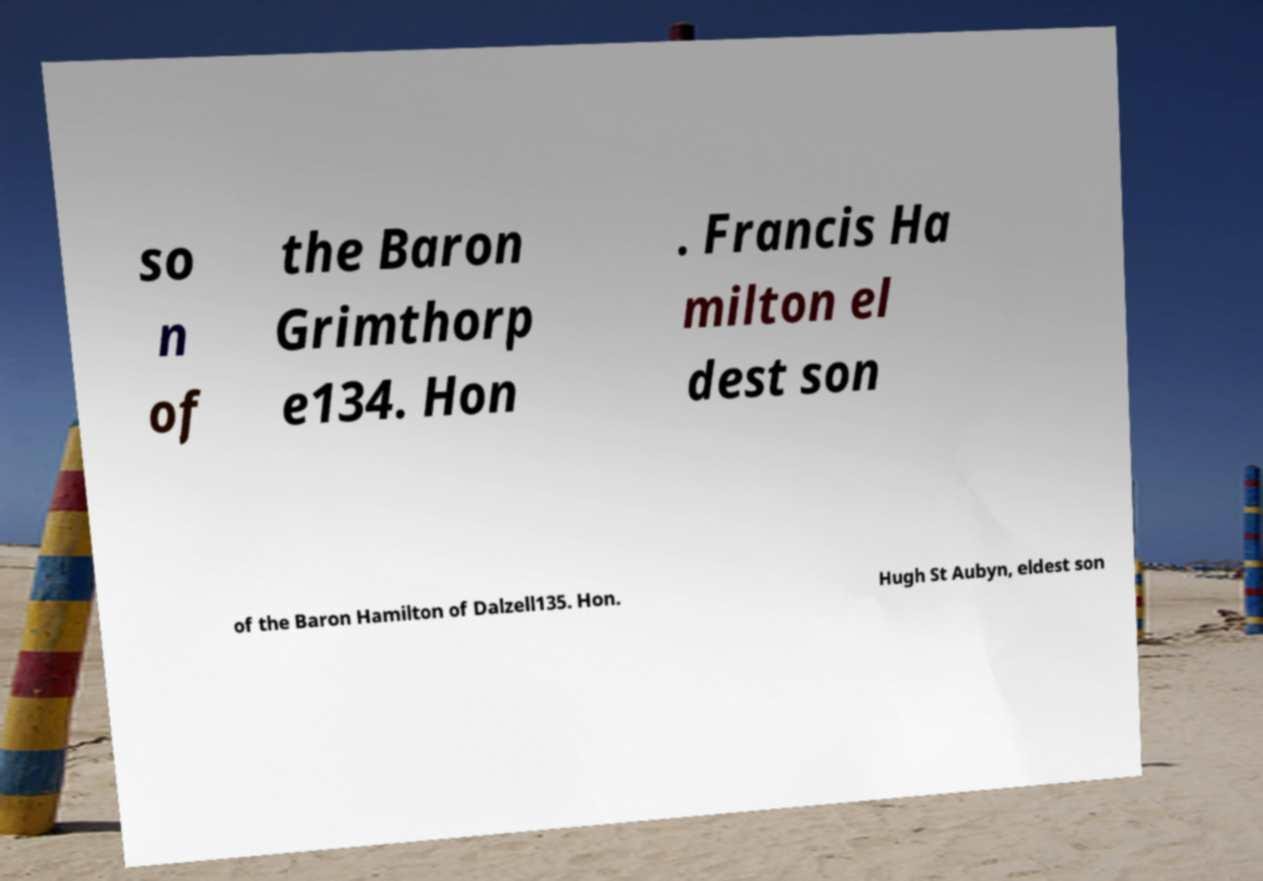For documentation purposes, I need the text within this image transcribed. Could you provide that? so n of the Baron Grimthorp e134. Hon . Francis Ha milton el dest son of the Baron Hamilton of Dalzell135. Hon. Hugh St Aubyn, eldest son 